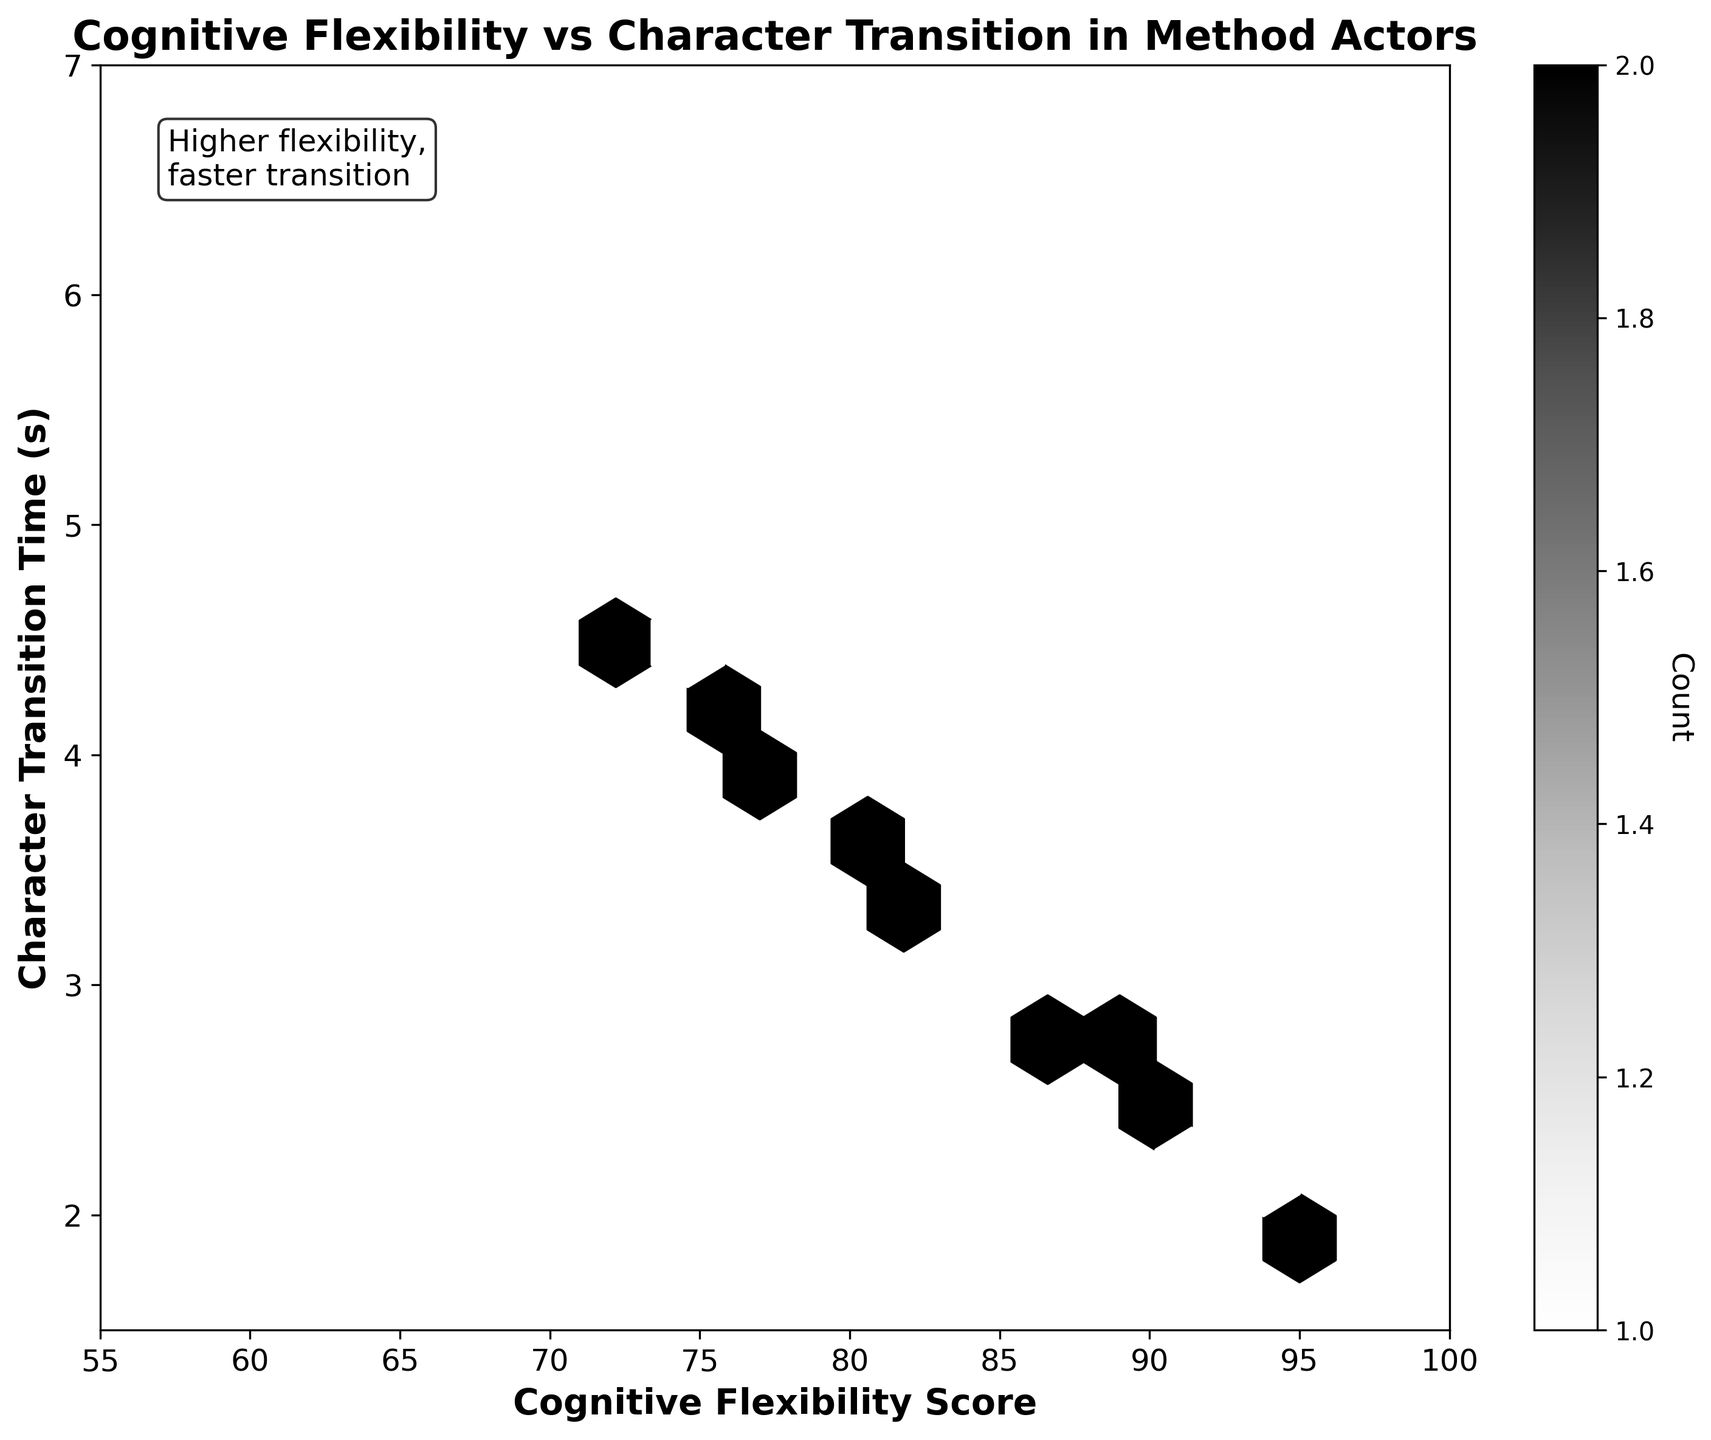What is the title of the figure? The title is in bold font at the top of the plot and reads, "Cognitive Flexibility vs Character Transition in Method Actors".
Answer: Cognitive Flexibility vs Character Transition in Method Actors What are the labels on the x and y axes? The x-axis label reads "Cognitive Flexibility Score" and the y-axis label reads "Character Transition Time (s)".
Answer: Cognitive Flexibility Score, Character Transition Time (s) What is the range of the x-axis? The x-axis range can be determined by the x-axis limits, which go from 55 to 100.
Answer: 55 to 100 How many bins have the highest count according to the color bar? The color bar indicates count density, and the darkest shade represents the highest count. Observing the hexbin plot reveals the few bins with the darkest shade.
Answer: Multiple Is there a general trend between Cognitive Flexibility Score and Character Transition Time? The scatter of hexagons in the plot suggests that higher Cognitive Flexibility Scores tend to correspond with faster Character Transition Times as shown through the clustering of darker hexagons in this area.
Answer: Yes For a Cognitive Flexibility Score of 90, what is the approximate Character Transition Time? By tracing vertically from the x-value of 90 to where it intersects with data points on the plot, the Character Transition Time is around 2.5 seconds.
Answer: 2.5 seconds What is the Cognitive Flexibility Score for a Character Transition Time of 5 seconds? By tracing horizontally from the y-value of 5 seconds, it intersects with x-values approximately in the range of 67-70. Fi
Answer: Around 67-70 How does the color intensity relate to the count of data points in a bin? The hexbin plot's darker shades indicate a higher count of data points within that bin, as shown on the color bar.
Answer: Darker shades indicate higher counts Where are the majority of the data points concentrated in terms of Cognitive Flexibility Scores and Character Transition Times? Most data points are concentrated between Cognitive Flexibility Scores of 70 to 95 and Character Transition Times of 2 to 4 seconds, indicating a cluster in this range.
Answer: 70-95 (Cognitive Flexibility Scores) and 2-4 seconds (Character Transition Time) Which section has the least number of data points according to the plot? The sections with the lightest shades or absence of hexagons usually indicate the least number of data points, found at the edges, particularly Cognitive Flexibility Scores below 65 and Character Transition Times above 6 seconds.
Answer: Scores below 65 and transition times above 6 seconds 